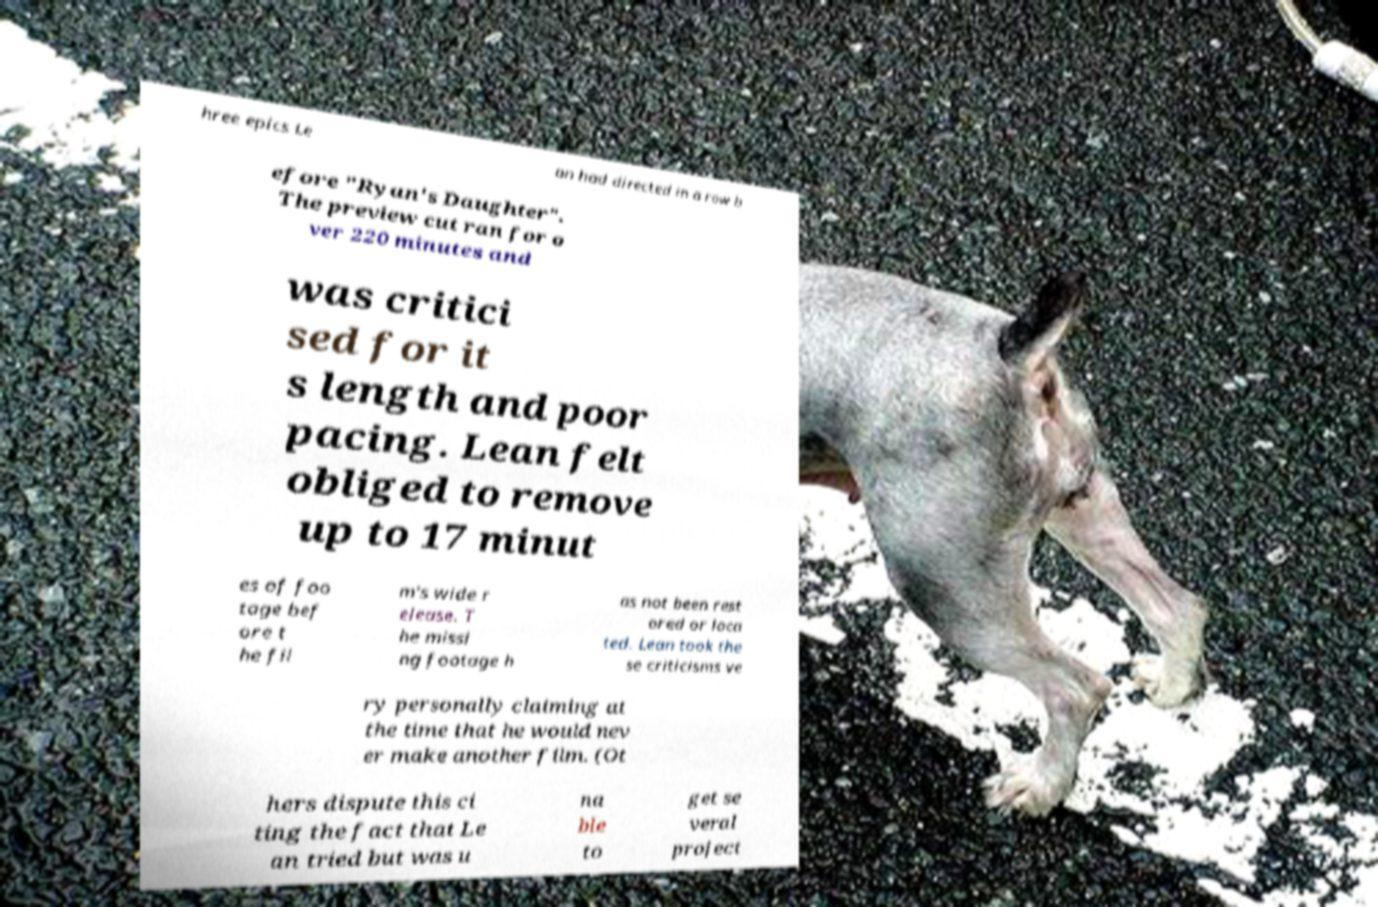Can you read and provide the text displayed in the image?This photo seems to have some interesting text. Can you extract and type it out for me? hree epics Le an had directed in a row b efore "Ryan's Daughter". The preview cut ran for o ver 220 minutes and was critici sed for it s length and poor pacing. Lean felt obliged to remove up to 17 minut es of foo tage bef ore t he fil m's wide r elease. T he missi ng footage h as not been rest ored or loca ted. Lean took the se criticisms ve ry personally claiming at the time that he would nev er make another film. (Ot hers dispute this ci ting the fact that Le an tried but was u na ble to get se veral project 